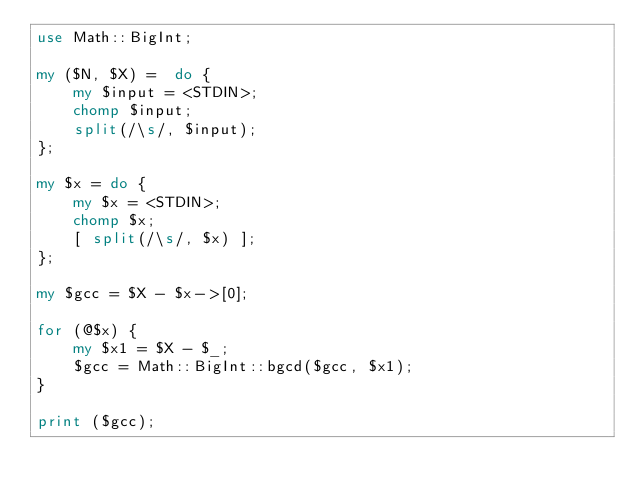Convert code to text. <code><loc_0><loc_0><loc_500><loc_500><_Perl_>use Math::BigInt;

my ($N, $X) =  do {
    my $input = <STDIN>;
    chomp $input;
    split(/\s/, $input);
};

my $x = do {
    my $x = <STDIN>;
    chomp $x;
    [ split(/\s/, $x) ];
};

my $gcc = $X - $x->[0];

for (@$x) {
    my $x1 = $X - $_;
    $gcc = Math::BigInt::bgcd($gcc, $x1);
}

print ($gcc);


</code> 